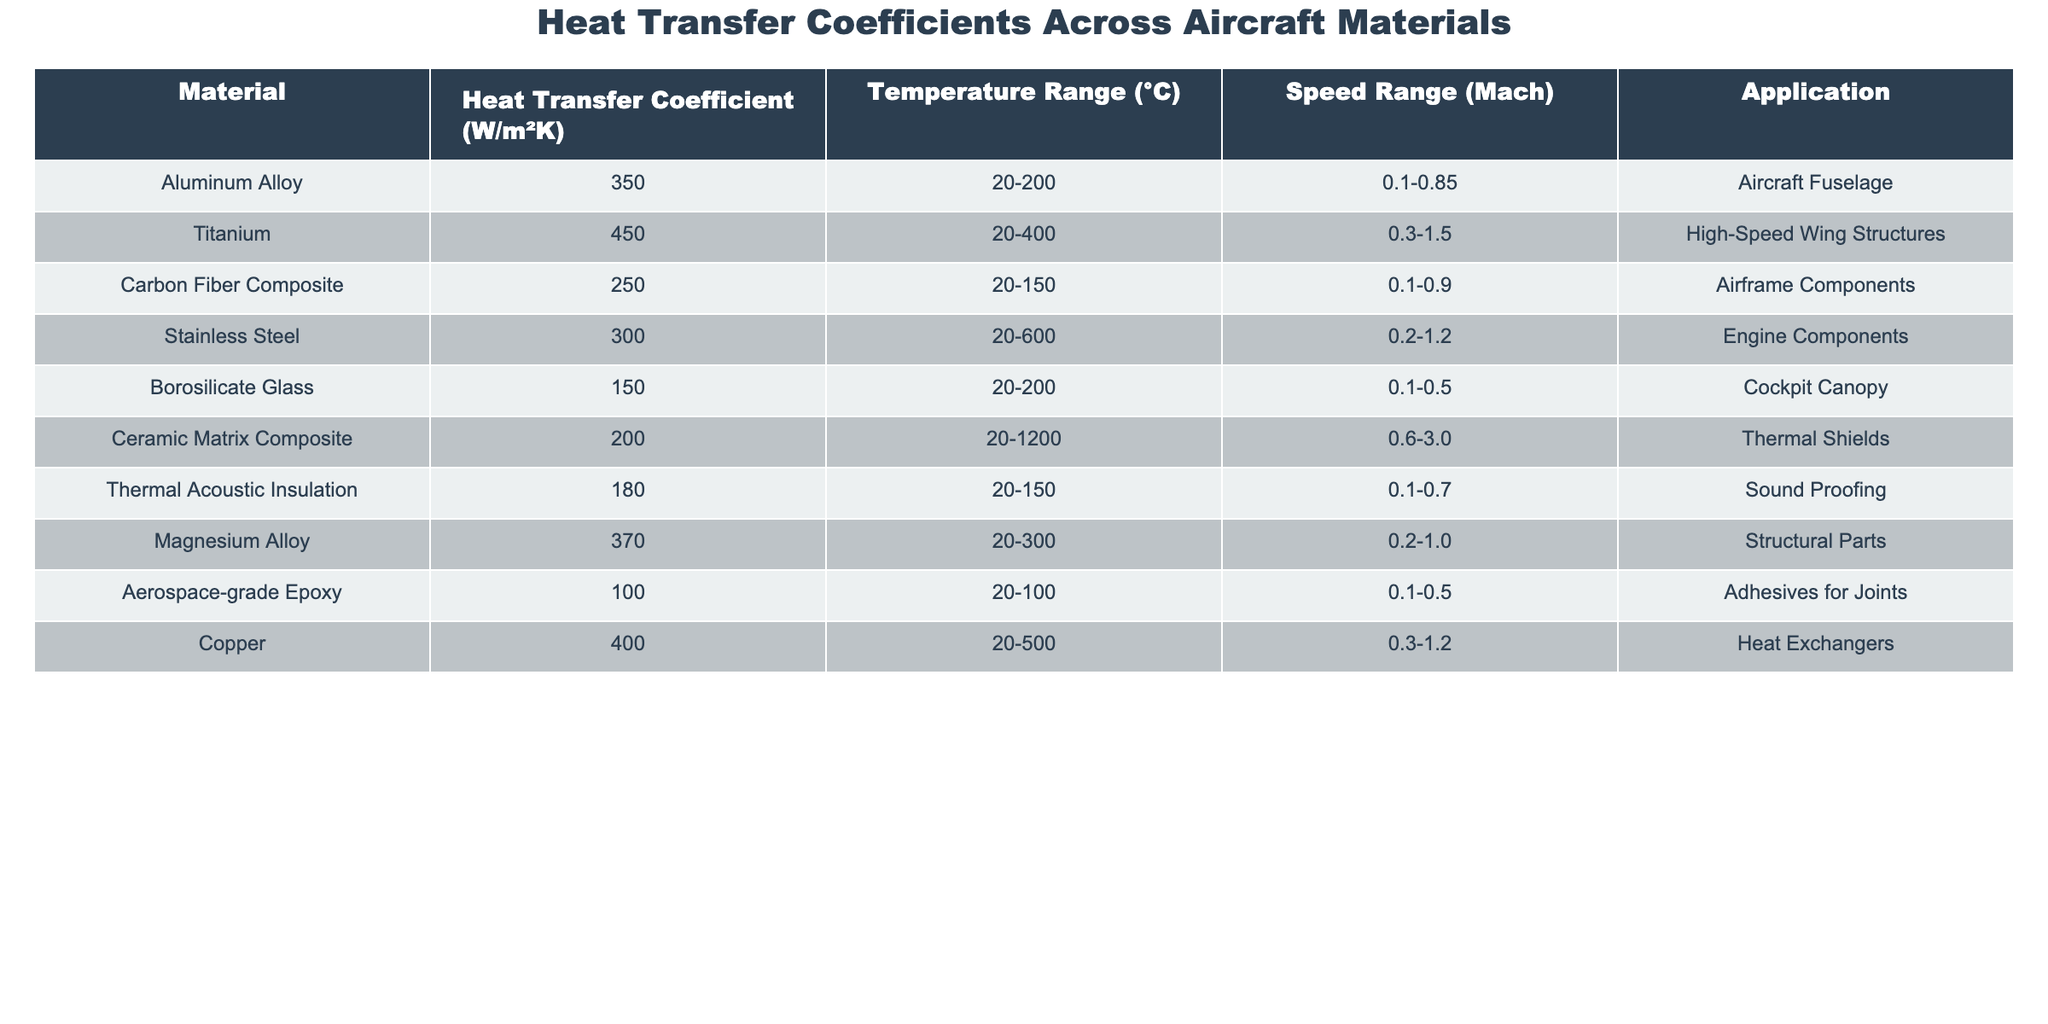What is the heat transfer coefficient for Titanium? The table shows that the heat transfer coefficient for Titanium is listed as 450 W/m²K.
Answer: 450 W/m²K Which material has the lowest heat transfer coefficient? By examining the table, the lowest heat transfer coefficient is for Aerospace-grade Epoxy, which is 100 W/m²K.
Answer: 100 W/m²K What is the speed range for Carbon Fiber Composite? According to the table, the speed range for Carbon Fiber Composite is 0.1 to 0.9 Mach.
Answer: 0.1-0.9 Mach Are Stainless Steel heat transfer coefficients greater than Magnesium Alloy? Checking the table, Stainless Steel has a heat transfer coefficient of 300 W/m²K, while Magnesium Alloy has 370 W/m²K; therefore, the statement is false.
Answer: False Which materials can be used in the temperature range of 20°C to 200°C? By looking at the table, the materials suitable for this temperature range are Aluminum Alloy, Borosilicate Glass, and Carbon Fiber Composite.
Answer: Aluminum Alloy, Borosilicate Glass, Carbon Fiber Composite What's the average heat transfer coefficient of materials used for thermal shields and soundproofing? The heat transfer coefficients for Thermal Shields (Ceramic Matrix Composite) and Sound Proofing (Thermal Acoustic Insulation) are 200 W/m²K and 180 W/m²K respectively. The average is (200 + 180) / 2 = 190 W/m²K.
Answer: 190 W/m²K Which material can withstand the highest temperature range? The material with the highest temperature range in the table is Ceramic Matrix Composite, which can withstand up to 1200°C.
Answer: Ceramic Matrix Composite What is the difference in heat transfer coefficients between Copper and Borosilicate Glass? The heat transfer coefficient for Copper is 400 W/m²K and for Borosilicate Glass, it is 150 W/m²K. The difference is 400 - 150 = 250 W/m²K.
Answer: 250 W/m²K Which materials are applicable for high-speed wing structures? The table indicates that the material applicable for high-speed wing structures is Titanium.
Answer: Titanium If we consider only the materials with heat transfer coefficients above 300 W/m²K, how many are there? The qualifying materials with coefficients above 300 W/m²K are Titanium (450), Magnesium Alloy (370), and Copper (400), totaling 3 materials.
Answer: 3 